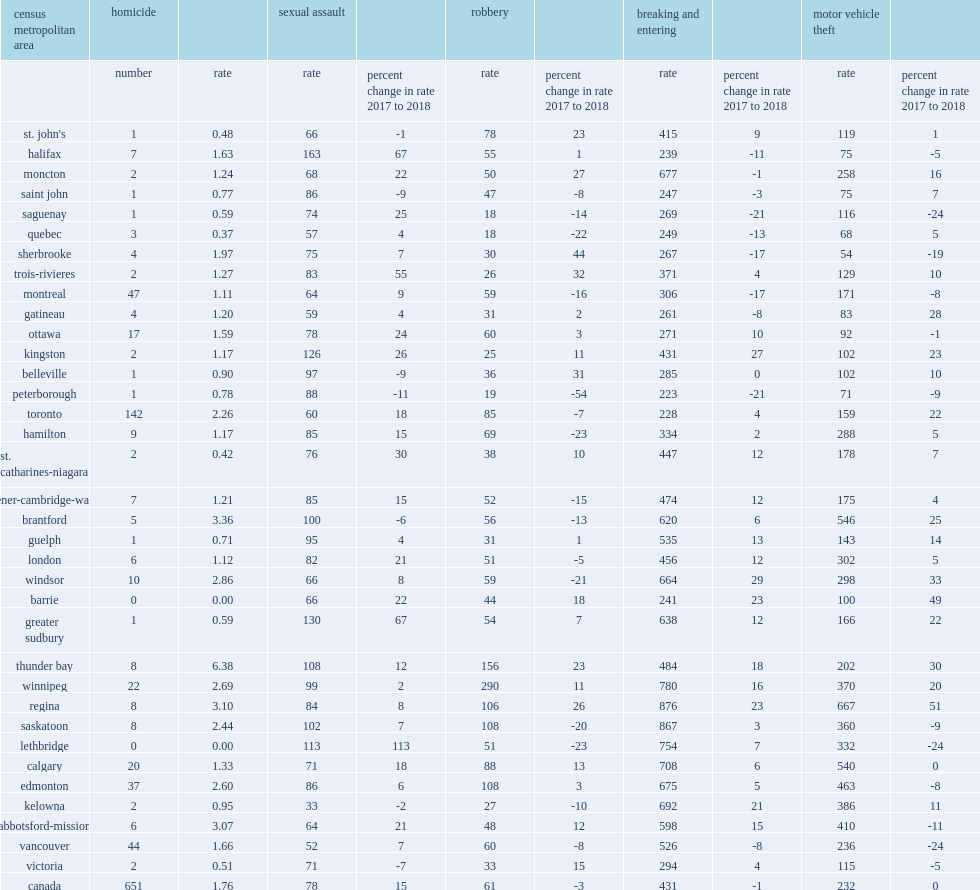What was the total of homicides in 2018, thunder bay continued to record the highest homicide rate among the cmas? 8.0. With a total of 8 homicides in 2018, how many homicides per 100,000 population in thunder bay which continued to record the highest homicide rate among the cmas? 6.38. 